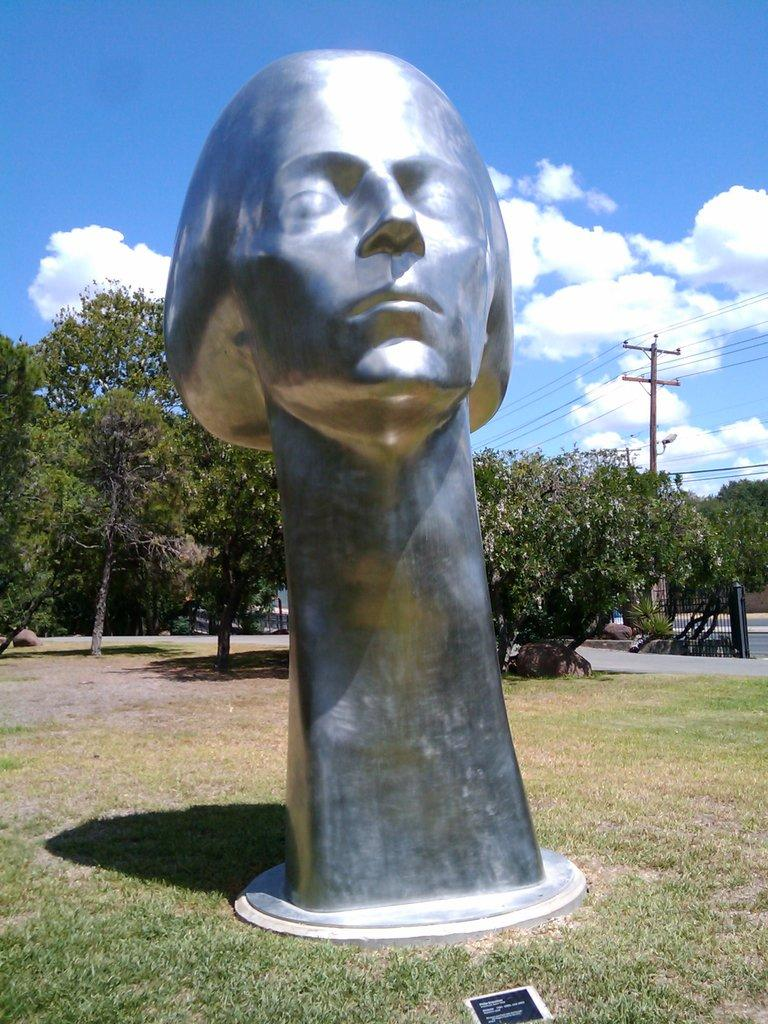What is the main subject in the middle of the image? There is a statue in the middle of the image. What type of vegetation is visible at the back side of the image? There are trees at the back side of the image. What is located on the right side of the image? There is an electric pole on the right side of the image. How would you describe the sky in the image? The sky is cloudy in the image. Can you see a glove hanging from the electric pole in the image? No, there is no glove present in the image. 